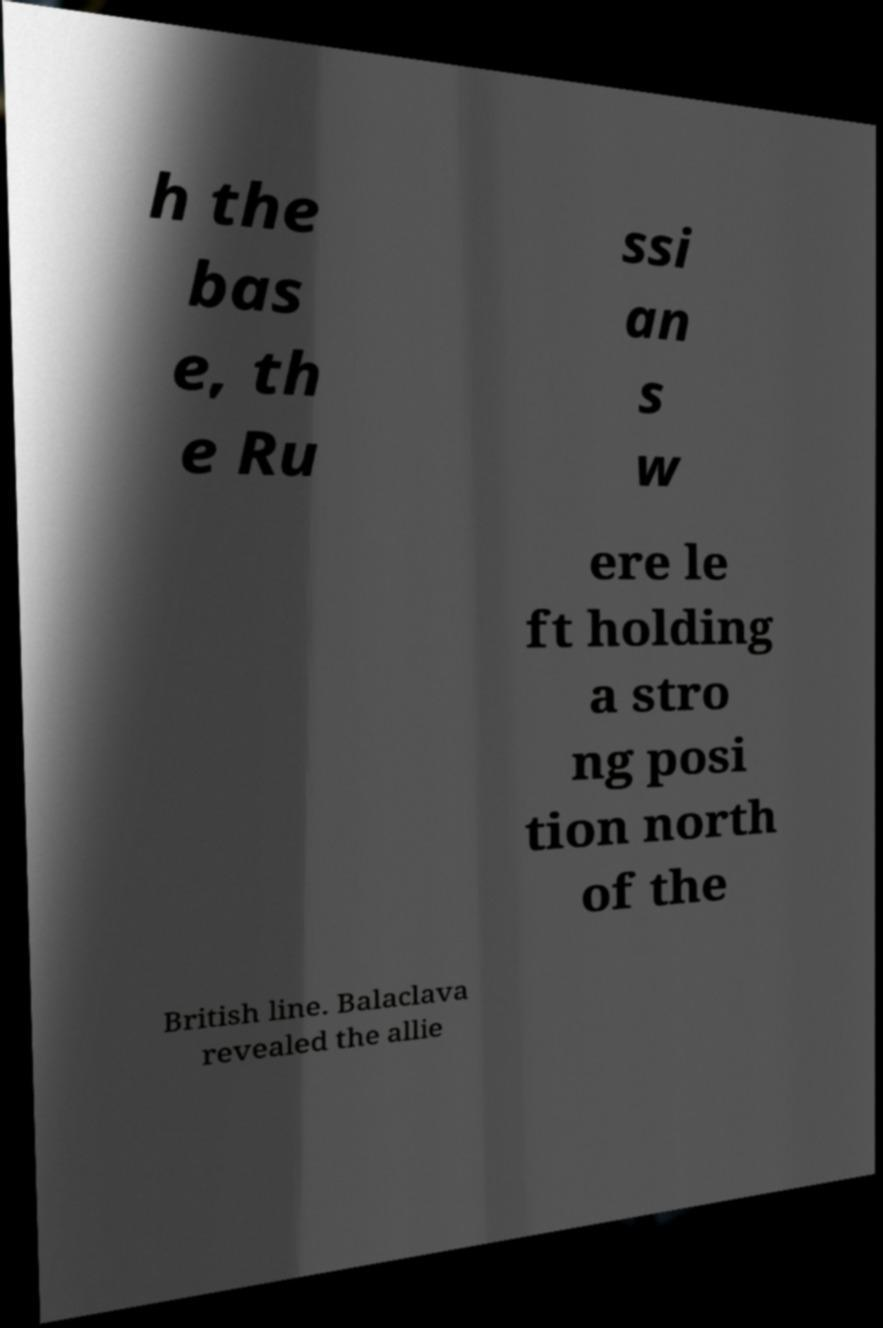Could you extract and type out the text from this image? h the bas e, th e Ru ssi an s w ere le ft holding a stro ng posi tion north of the British line. Balaclava revealed the allie 